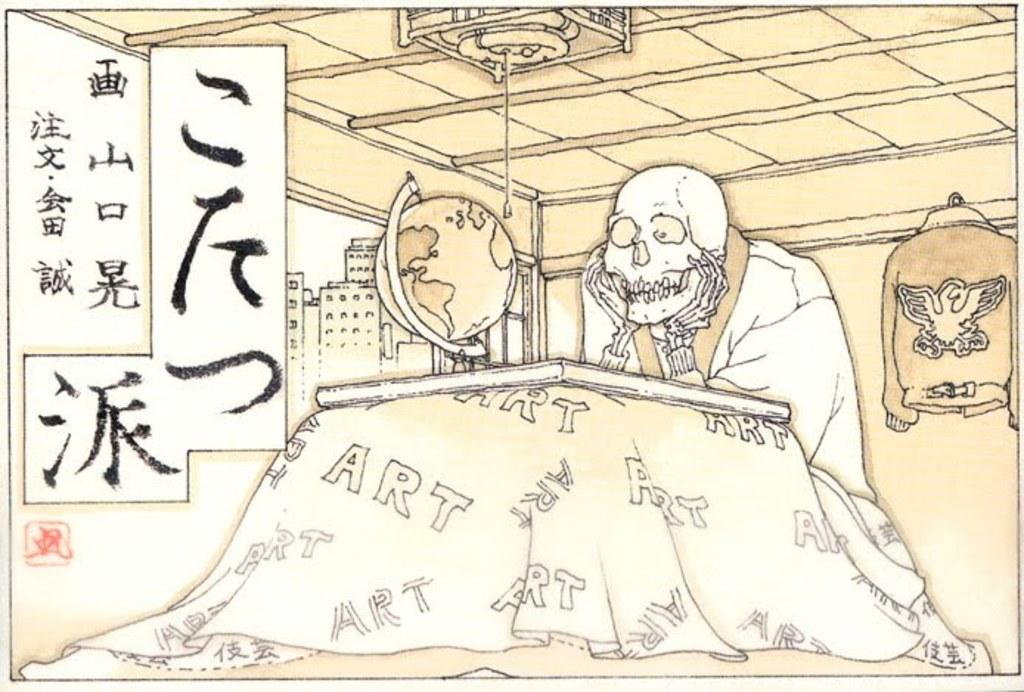What is the main subject of the image? The main subject of the image is an art of a skeleton. What is the skeleton doing in the image? The skeleton is sitting in front of a table in the image. What object is on the table in the image? There is a globe on the table in the image. What can be seen on the wall on the right side of the image? There is a shirt hanging on the wall on the right side. What is on the left side of the image? There is a cardboard with text on the left side. How many ducks are present in the image? There are no ducks present in the image. What type of care is the skeleton receiving in the image? The image does not depict any care being provided to the skeleton. 